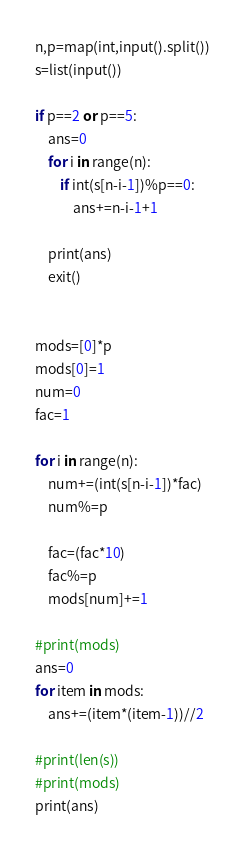Convert code to text. <code><loc_0><loc_0><loc_500><loc_500><_Python_>n,p=map(int,input().split())
s=list(input())

if p==2 or p==5:
    ans=0
    for i in range(n):
        if int(s[n-i-1])%p==0:
            ans+=n-i-1+1

    print(ans)
    exit()


mods=[0]*p
mods[0]=1
num=0
fac=1

for i in range(n):
    num+=(int(s[n-i-1])*fac)
    num%=p

    fac=(fac*10)
    fac%=p
    mods[num]+=1

#print(mods)
ans=0
for item in mods:
    ans+=(item*(item-1))//2

#print(len(s))
#print(mods)
print(ans)



</code> 